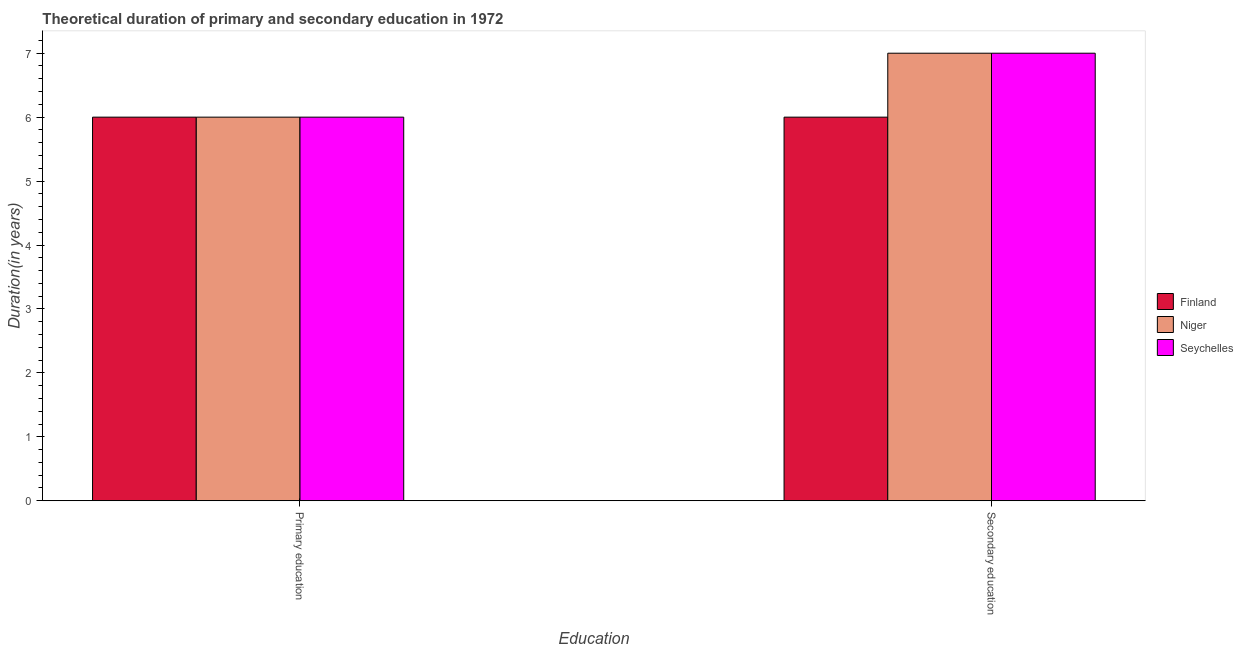How many different coloured bars are there?
Offer a very short reply. 3. How many bars are there on the 1st tick from the right?
Make the answer very short. 3. What is the label of the 1st group of bars from the left?
Offer a very short reply. Primary education. What is the duration of secondary education in Seychelles?
Offer a very short reply. 7. Across all countries, what is the maximum duration of secondary education?
Make the answer very short. 7. Across all countries, what is the minimum duration of secondary education?
Your answer should be very brief. 6. In which country was the duration of primary education minimum?
Offer a terse response. Finland. What is the total duration of secondary education in the graph?
Your answer should be very brief. 20. What is the difference between the duration of secondary education in Niger and that in Finland?
Offer a very short reply. 1. What is the difference between the duration of secondary education in Finland and the duration of primary education in Niger?
Provide a short and direct response. 0. What is the average duration of primary education per country?
Keep it short and to the point. 6. What is the difference between the duration of primary education and duration of secondary education in Seychelles?
Provide a short and direct response. -1. In how many countries, is the duration of secondary education greater than 0.8 years?
Your answer should be compact. 3. What is the ratio of the duration of secondary education in Niger to that in Finland?
Make the answer very short. 1.17. Is the duration of secondary education in Seychelles less than that in Niger?
Ensure brevity in your answer.  No. How many bars are there?
Your answer should be compact. 6. How many countries are there in the graph?
Make the answer very short. 3. What is the difference between two consecutive major ticks on the Y-axis?
Your response must be concise. 1. Are the values on the major ticks of Y-axis written in scientific E-notation?
Make the answer very short. No. Does the graph contain any zero values?
Offer a very short reply. No. How many legend labels are there?
Ensure brevity in your answer.  3. What is the title of the graph?
Provide a short and direct response. Theoretical duration of primary and secondary education in 1972. What is the label or title of the X-axis?
Your answer should be very brief. Education. What is the label or title of the Y-axis?
Provide a succinct answer. Duration(in years). What is the Duration(in years) in Niger in Primary education?
Offer a terse response. 6. What is the Duration(in years) of Seychelles in Primary education?
Ensure brevity in your answer.  6. Across all Education, what is the maximum Duration(in years) in Finland?
Keep it short and to the point. 6. Across all Education, what is the maximum Duration(in years) of Seychelles?
Offer a very short reply. 7. Across all Education, what is the minimum Duration(in years) in Finland?
Give a very brief answer. 6. Across all Education, what is the minimum Duration(in years) in Niger?
Your answer should be compact. 6. Across all Education, what is the minimum Duration(in years) of Seychelles?
Offer a terse response. 6. What is the total Duration(in years) of Finland in the graph?
Offer a very short reply. 12. What is the difference between the Duration(in years) of Finland in Primary education and that in Secondary education?
Offer a very short reply. 0. What is the difference between the Duration(in years) of Niger in Primary education and that in Secondary education?
Ensure brevity in your answer.  -1. What is the difference between the Duration(in years) in Finland in Primary education and the Duration(in years) in Niger in Secondary education?
Offer a very short reply. -1. What is the difference between the Duration(in years) of Finland in Primary education and the Duration(in years) of Seychelles in Secondary education?
Offer a very short reply. -1. What is the difference between the Duration(in years) of Niger in Primary education and the Duration(in years) of Seychelles in Secondary education?
Offer a terse response. -1. What is the average Duration(in years) in Finland per Education?
Give a very brief answer. 6. What is the average Duration(in years) of Niger per Education?
Your answer should be compact. 6.5. What is the difference between the Duration(in years) of Finland and Duration(in years) of Niger in Primary education?
Make the answer very short. 0. What is the difference between the Duration(in years) in Finland and Duration(in years) in Seychelles in Secondary education?
Your answer should be very brief. -1. What is the difference between the Duration(in years) in Niger and Duration(in years) in Seychelles in Secondary education?
Ensure brevity in your answer.  0. What is the ratio of the Duration(in years) in Niger in Primary education to that in Secondary education?
Your answer should be very brief. 0.86. What is the ratio of the Duration(in years) in Seychelles in Primary education to that in Secondary education?
Provide a short and direct response. 0.86. What is the difference between the highest and the second highest Duration(in years) in Finland?
Your response must be concise. 0. What is the difference between the highest and the lowest Duration(in years) in Finland?
Keep it short and to the point. 0. What is the difference between the highest and the lowest Duration(in years) of Niger?
Provide a succinct answer. 1. What is the difference between the highest and the lowest Duration(in years) in Seychelles?
Your response must be concise. 1. 